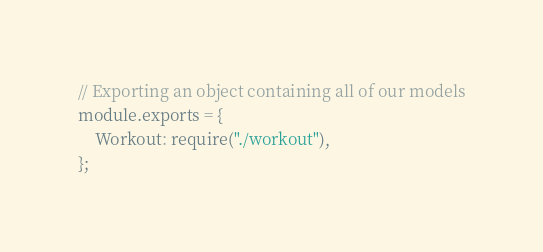<code> <loc_0><loc_0><loc_500><loc_500><_JavaScript_>// Exporting an object containing all of our models
module.exports = {
    Workout: require("./workout"),  
};</code> 